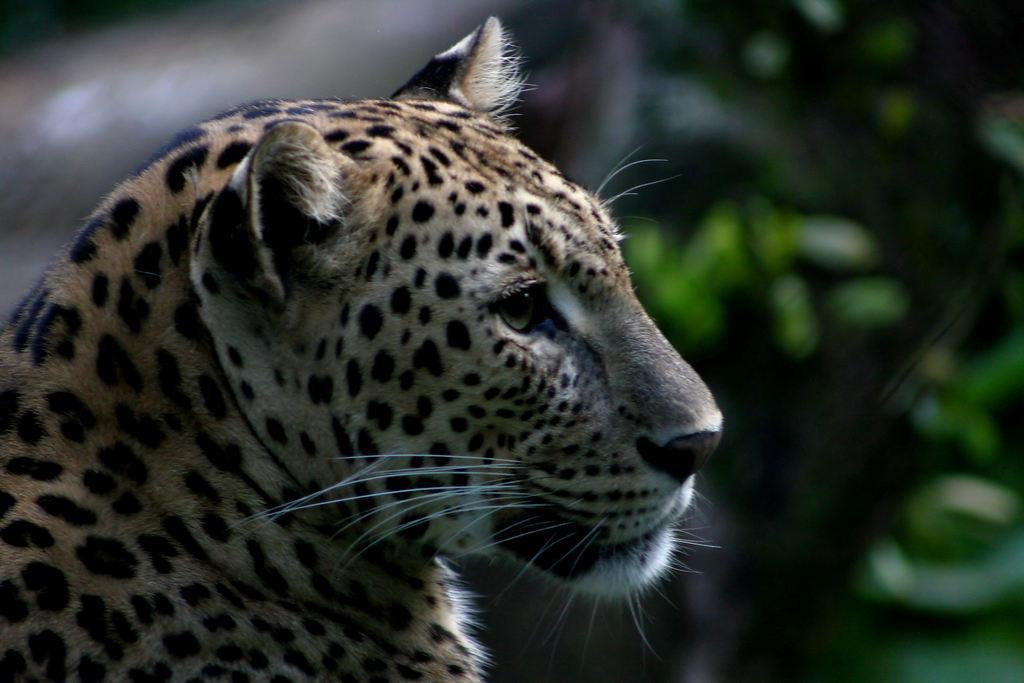Describe this image in one or two sentences. In this image we can see a leopard on the left side. In the background the image is blur but we can see objects. 